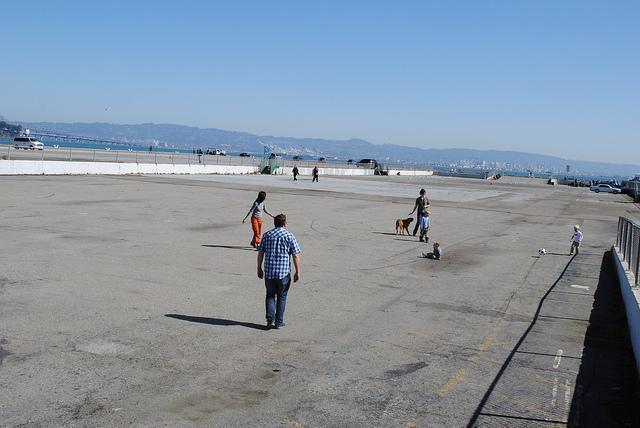How many cows are there?
Give a very brief answer. 0. 